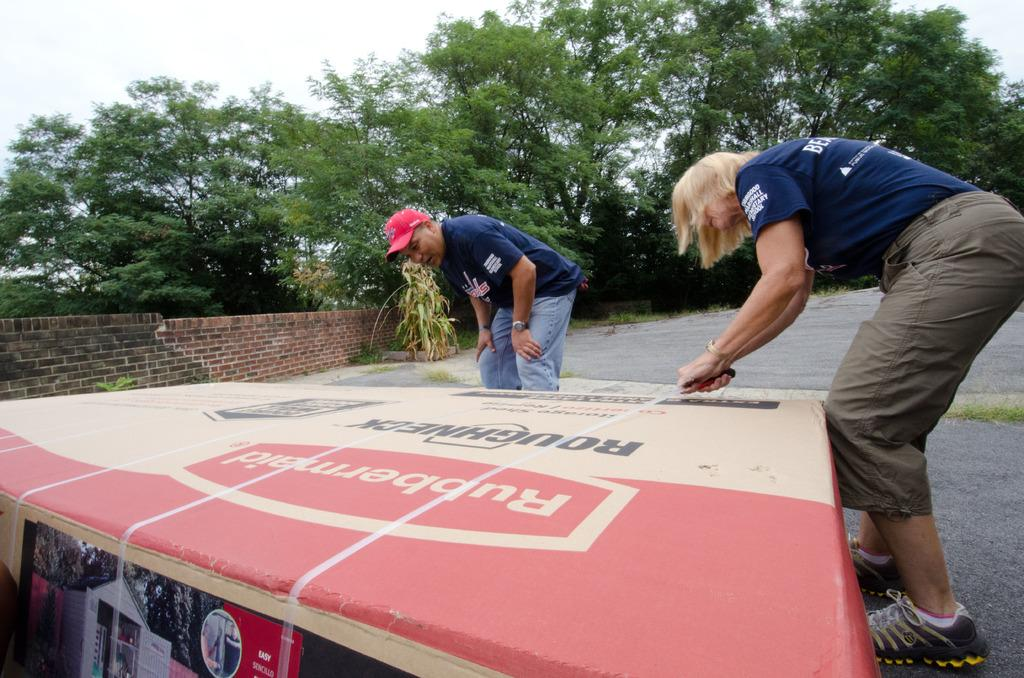How many persons are in the image? There are persons standing in the image. What are the persons holding in the image? The persons are holding a cardboard carton. Where is the cardboard carton placed in the image? The cardboard carton is placed on the road. What type of vegetation can be seen in the image? There are plants and trees visible in the image. What is visible in the background of the image? The sky is visible in the image. What type of seat can be seen in the image? There is no seat present in the image. Can you tell me where the zoo is located in the image? There is no zoo present in the image. 